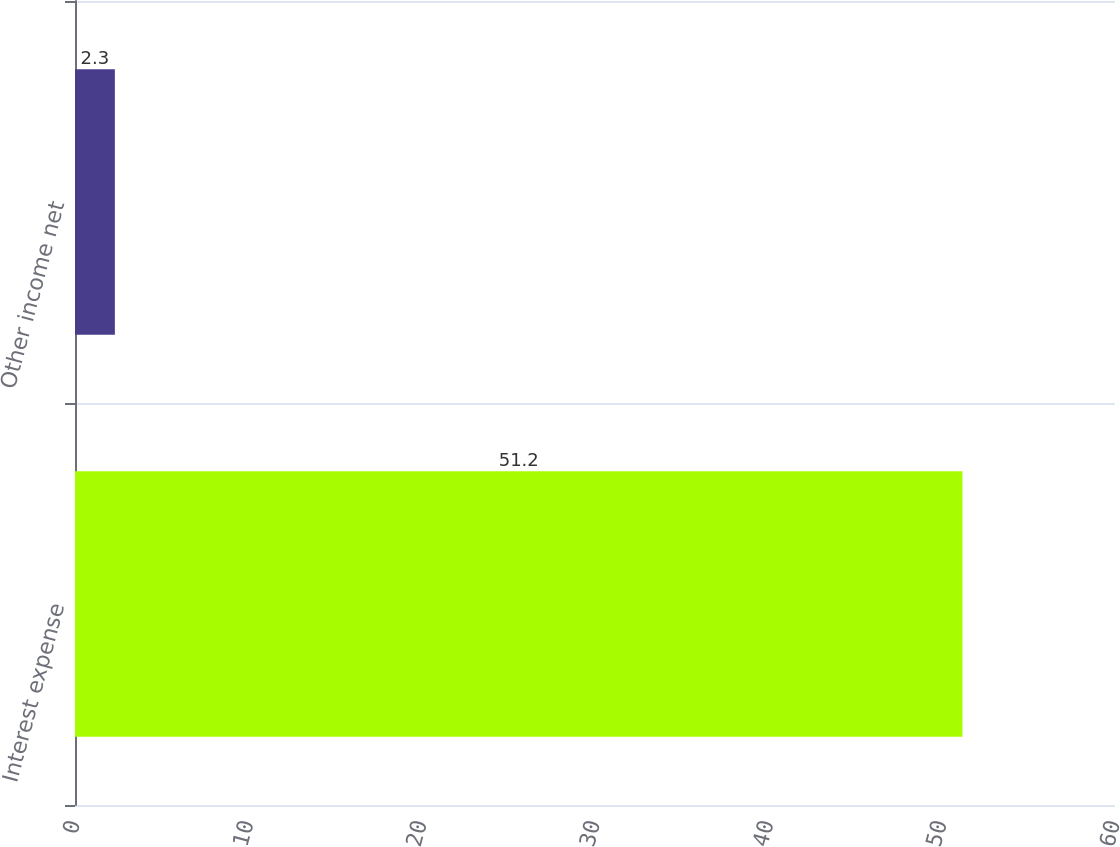Convert chart to OTSL. <chart><loc_0><loc_0><loc_500><loc_500><bar_chart><fcel>Interest expense<fcel>Other income net<nl><fcel>51.2<fcel>2.3<nl></chart> 